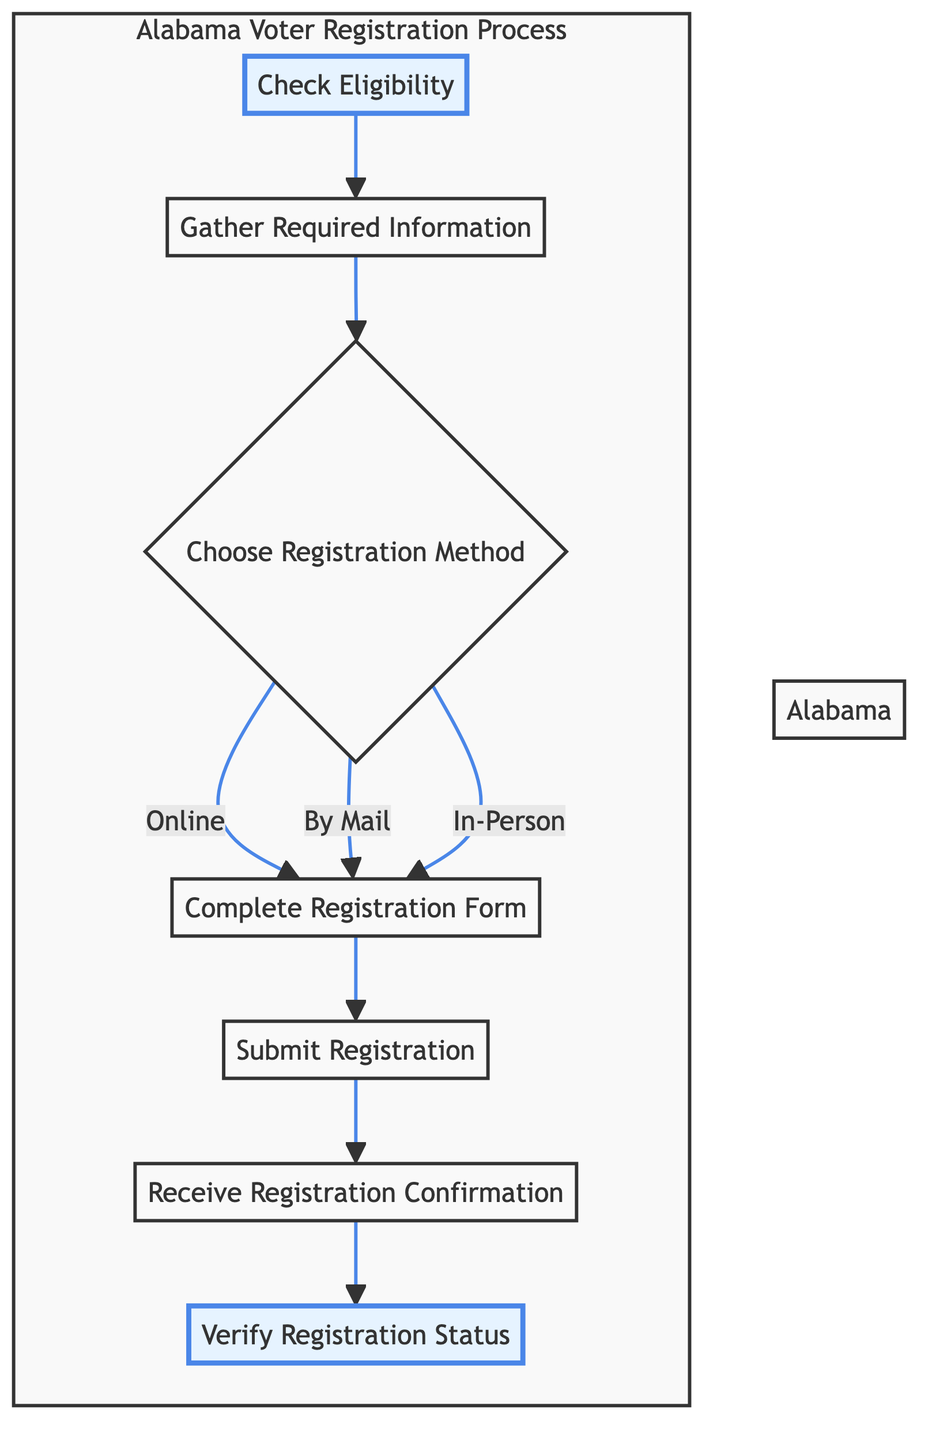What is the first step in the voter registration process? The first step is "Check Eligibility," which is indicated as the starting point of the flow chart.
Answer: Check Eligibility How many steps are in the voter registration process? By counting the steps from "Check Eligibility" to "Verify Registration Status," we find there are seven distinct steps.
Answer: Seven What action follows "Gather Required Information"? The flow from "Gather Required Information" leads directly to "Choose Registration Method," which is the next action in the process.
Answer: Choose Registration Method Which methods can voters choose for registration? The diagram specifies three methods: "Online," "By Mail," and "In-Person," which come from the decision node "Choose Registration Method."
Answer: Online, By Mail, In-Person What happens after completing the registration form? Immediately after "Complete Registration Form," the next step is "Submit Registration." This indicates that submission is the next required action.
Answer: Submit Registration How does the flow end in the diagram? The flowchart concludes with the step "Verify Registration Status," which shows that the process ultimately leads to confirming one's registration before election day.
Answer: Verify Registration Status What is the relationship between "Submit Registration" and "Receive Registration Confirmation"? "Submit Registration" is a prerequisite to "Receive Registration Confirmation," meaning registration must be submitted before confirmation can be received.
Answer: Prerequisite What step must be completed before checking the registration status? Before verifying registration status, the preceding step is "Receive Registration Confirmation," indicating that confirmation must occur first.
Answer: Receive Registration Confirmation In which step is the voter required to check their eligibility? "Check Eligibility" is the specified step for voters to ensure they meet the necessary qualifications to register.
Answer: Check Eligibility 